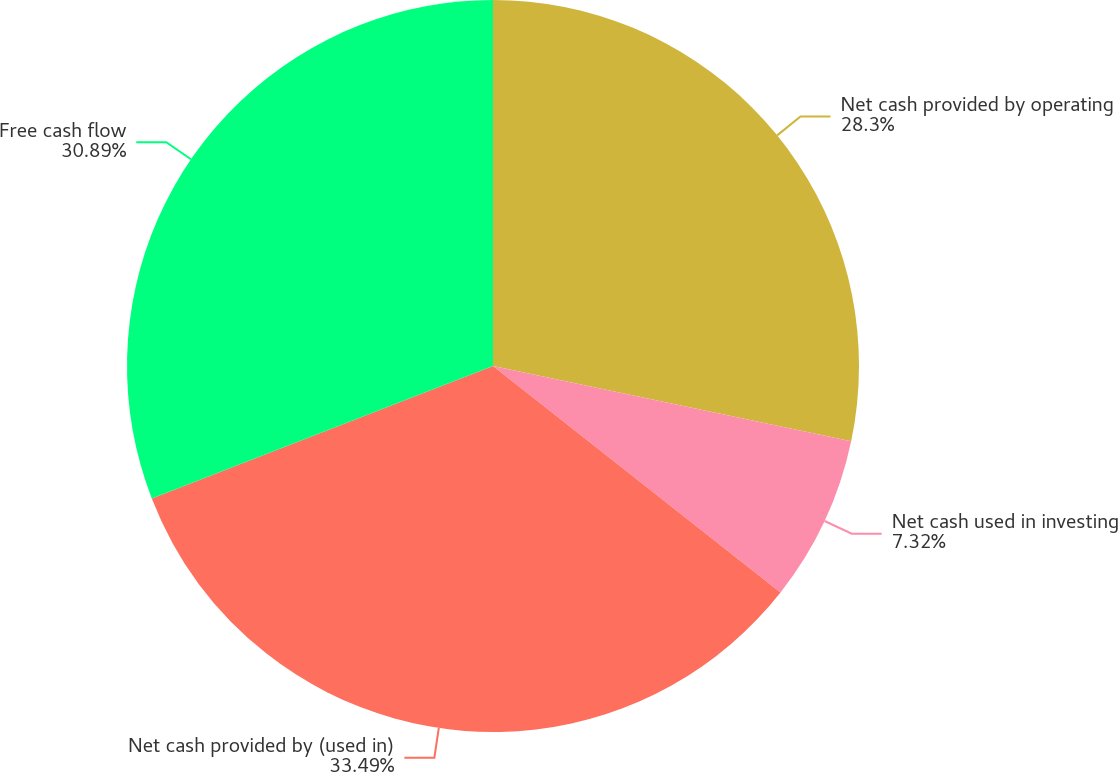<chart> <loc_0><loc_0><loc_500><loc_500><pie_chart><fcel>Net cash provided by operating<fcel>Net cash used in investing<fcel>Net cash provided by (used in)<fcel>Free cash flow<nl><fcel>28.3%<fcel>7.32%<fcel>33.49%<fcel>30.89%<nl></chart> 